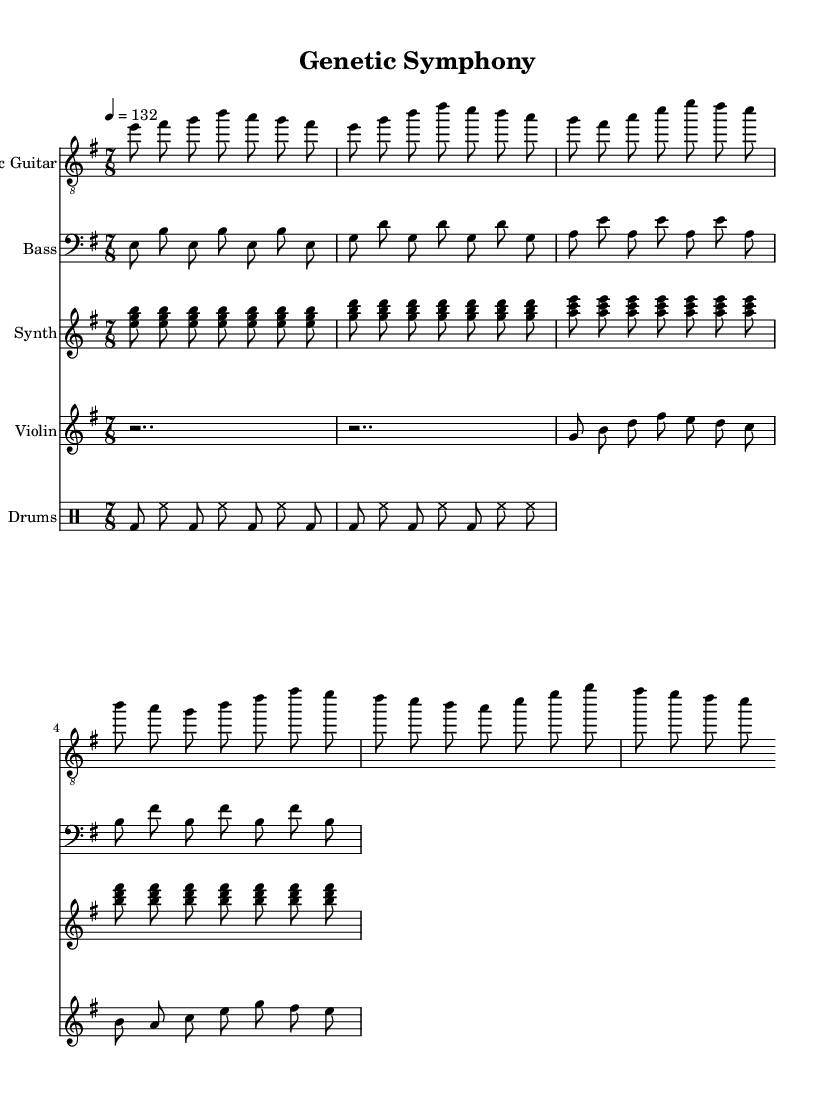What is the key signature of this music? The key signature is E minor, which has one sharp (F#). This can be identified from the clef and key signature at the beginning of the music sheet.
Answer: E minor What is the time signature of this music? The time signature is 7/8, indicated at the beginning of the sheet music. It shows that each measure contains seven eighth notes.
Answer: 7/8 What is the tempo marking for this piece? The tempo marking is 4 equals 132, which indicates that there are 132 beats per minute at a quarter note. This marking is found at the beginning of the music, within the header information.
Answer: 132 Which instrument plays the melody in this arrangement? The electric guitar plays the melody, as seen in the treble clef staff and the distinct rhythm and notes that suggest a leading role. The guitar part has the most prominent and recognizable melodic content throughout the piece.
Answer: Electric Guitar How many bars are in the electric guitar part? The electric guitar part consists of 6 bars (or measures), which can be counted by the number of vertical lines that separate the segments of music within the staff.
Answer: 6 What type of instrumentation is used in this piece? The instrumentation includes electric guitar, bass guitar, synthesizer, violin, and drums, reflecting a typical progressive rock ensemble with a mix of both traditional and electronic instruments. This can be deduced from the labels of the different staves in the sheet music.
Answer: Electric Guitar, Bass, Synthesizer, Violin, Drums What is the rhythmic feel of the piece based on the time signature? The rhythmic feel is complex and mixed due to the 7/8 time signature, which creates an offbeat and progressive rock feel, making it less predictable than common time signatures. This is evident in the arrangement and grouping of notes.
Answer: Complex 